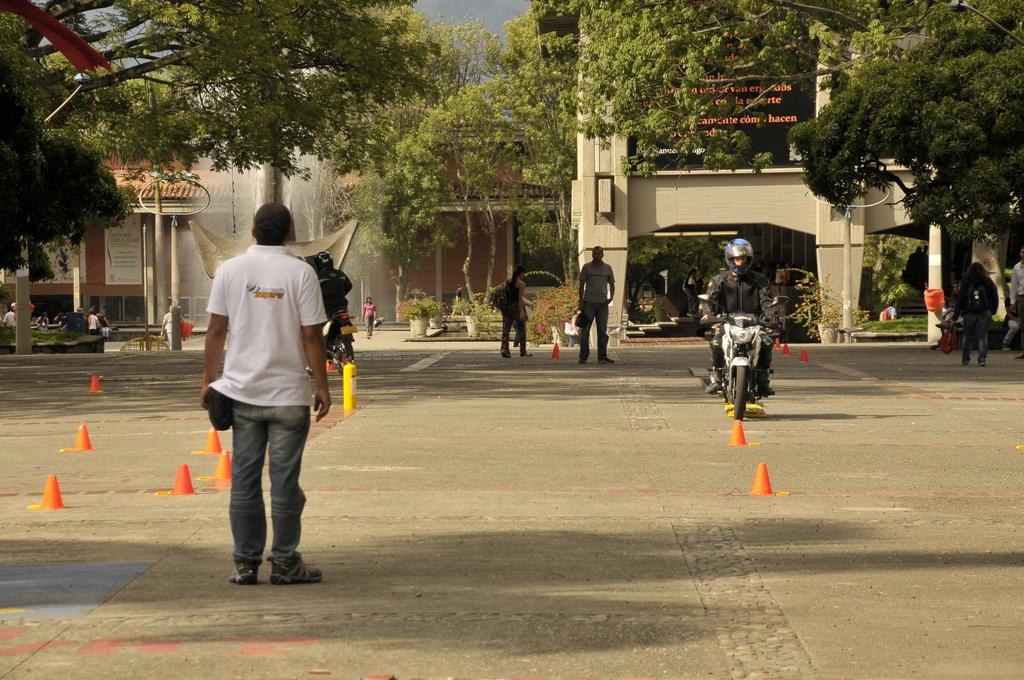Who or what can be seen in the image? There are people in the image. What else is visible on the road in the image? There are vehicles on the road in the image. What can be seen in the distance in the image? There are trees in the background of the image. What else can be seen in the background of the image? There are buildings with text written on them in the background of the image. What type of business is being conducted by the man in the image? There is no man conducting business in the image; the image only shows people, vehicles, trees, and buildings with text. 